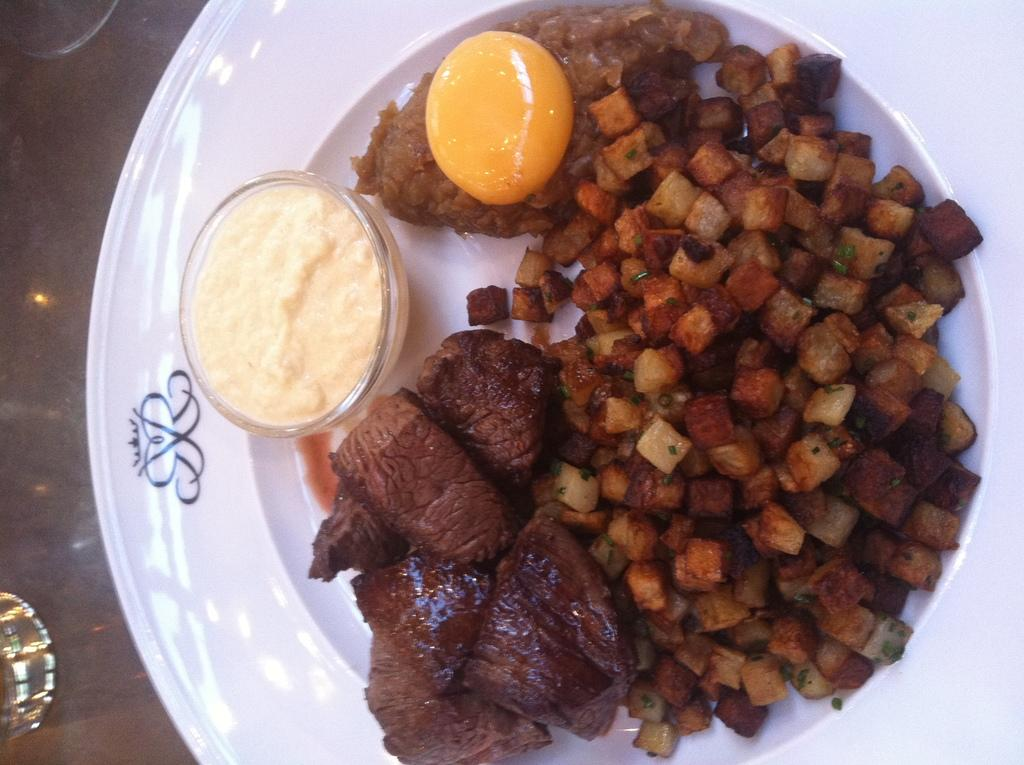What piece of furniture is present in the image? There is a table in the image. What is placed on the table? There is a plate on the table. What is on the plate? There is a food item on the plate. How many children are playing in the harbor in the image? There is no harbor or children present in the image. 